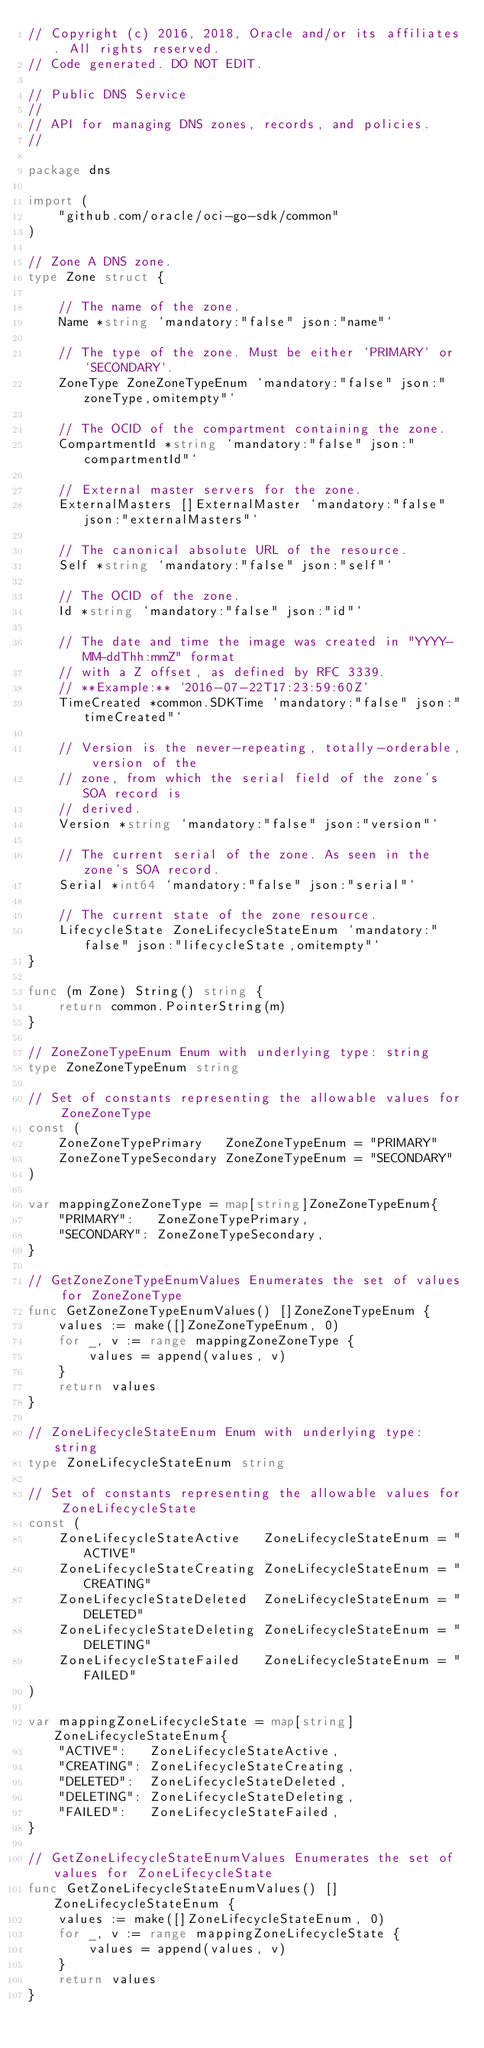<code> <loc_0><loc_0><loc_500><loc_500><_Go_>// Copyright (c) 2016, 2018, Oracle and/or its affiliates. All rights reserved.
// Code generated. DO NOT EDIT.

// Public DNS Service
//
// API for managing DNS zones, records, and policies.
//

package dns

import (
	"github.com/oracle/oci-go-sdk/common"
)

// Zone A DNS zone.
type Zone struct {

	// The name of the zone.
	Name *string `mandatory:"false" json:"name"`

	// The type of the zone. Must be either `PRIMARY` or `SECONDARY`.
	ZoneType ZoneZoneTypeEnum `mandatory:"false" json:"zoneType,omitempty"`

	// The OCID of the compartment containing the zone.
	CompartmentId *string `mandatory:"false" json:"compartmentId"`

	// External master servers for the zone.
	ExternalMasters []ExternalMaster `mandatory:"false" json:"externalMasters"`

	// The canonical absolute URL of the resource.
	Self *string `mandatory:"false" json:"self"`

	// The OCID of the zone.
	Id *string `mandatory:"false" json:"id"`

	// The date and time the image was created in "YYYY-MM-ddThh:mmZ" format
	// with a Z offset, as defined by RFC 3339.
	// **Example:** `2016-07-22T17:23:59:60Z`
	TimeCreated *common.SDKTime `mandatory:"false" json:"timeCreated"`

	// Version is the never-repeating, totally-orderable, version of the
	// zone, from which the serial field of the zone's SOA record is
	// derived.
	Version *string `mandatory:"false" json:"version"`

	// The current serial of the zone. As seen in the zone's SOA record.
	Serial *int64 `mandatory:"false" json:"serial"`

	// The current state of the zone resource.
	LifecycleState ZoneLifecycleStateEnum `mandatory:"false" json:"lifecycleState,omitempty"`
}

func (m Zone) String() string {
	return common.PointerString(m)
}

// ZoneZoneTypeEnum Enum with underlying type: string
type ZoneZoneTypeEnum string

// Set of constants representing the allowable values for ZoneZoneType
const (
	ZoneZoneTypePrimary   ZoneZoneTypeEnum = "PRIMARY"
	ZoneZoneTypeSecondary ZoneZoneTypeEnum = "SECONDARY"
)

var mappingZoneZoneType = map[string]ZoneZoneTypeEnum{
	"PRIMARY":   ZoneZoneTypePrimary,
	"SECONDARY": ZoneZoneTypeSecondary,
}

// GetZoneZoneTypeEnumValues Enumerates the set of values for ZoneZoneType
func GetZoneZoneTypeEnumValues() []ZoneZoneTypeEnum {
	values := make([]ZoneZoneTypeEnum, 0)
	for _, v := range mappingZoneZoneType {
		values = append(values, v)
	}
	return values
}

// ZoneLifecycleStateEnum Enum with underlying type: string
type ZoneLifecycleStateEnum string

// Set of constants representing the allowable values for ZoneLifecycleState
const (
	ZoneLifecycleStateActive   ZoneLifecycleStateEnum = "ACTIVE"
	ZoneLifecycleStateCreating ZoneLifecycleStateEnum = "CREATING"
	ZoneLifecycleStateDeleted  ZoneLifecycleStateEnum = "DELETED"
	ZoneLifecycleStateDeleting ZoneLifecycleStateEnum = "DELETING"
	ZoneLifecycleStateFailed   ZoneLifecycleStateEnum = "FAILED"
)

var mappingZoneLifecycleState = map[string]ZoneLifecycleStateEnum{
	"ACTIVE":   ZoneLifecycleStateActive,
	"CREATING": ZoneLifecycleStateCreating,
	"DELETED":  ZoneLifecycleStateDeleted,
	"DELETING": ZoneLifecycleStateDeleting,
	"FAILED":   ZoneLifecycleStateFailed,
}

// GetZoneLifecycleStateEnumValues Enumerates the set of values for ZoneLifecycleState
func GetZoneLifecycleStateEnumValues() []ZoneLifecycleStateEnum {
	values := make([]ZoneLifecycleStateEnum, 0)
	for _, v := range mappingZoneLifecycleState {
		values = append(values, v)
	}
	return values
}
</code> 